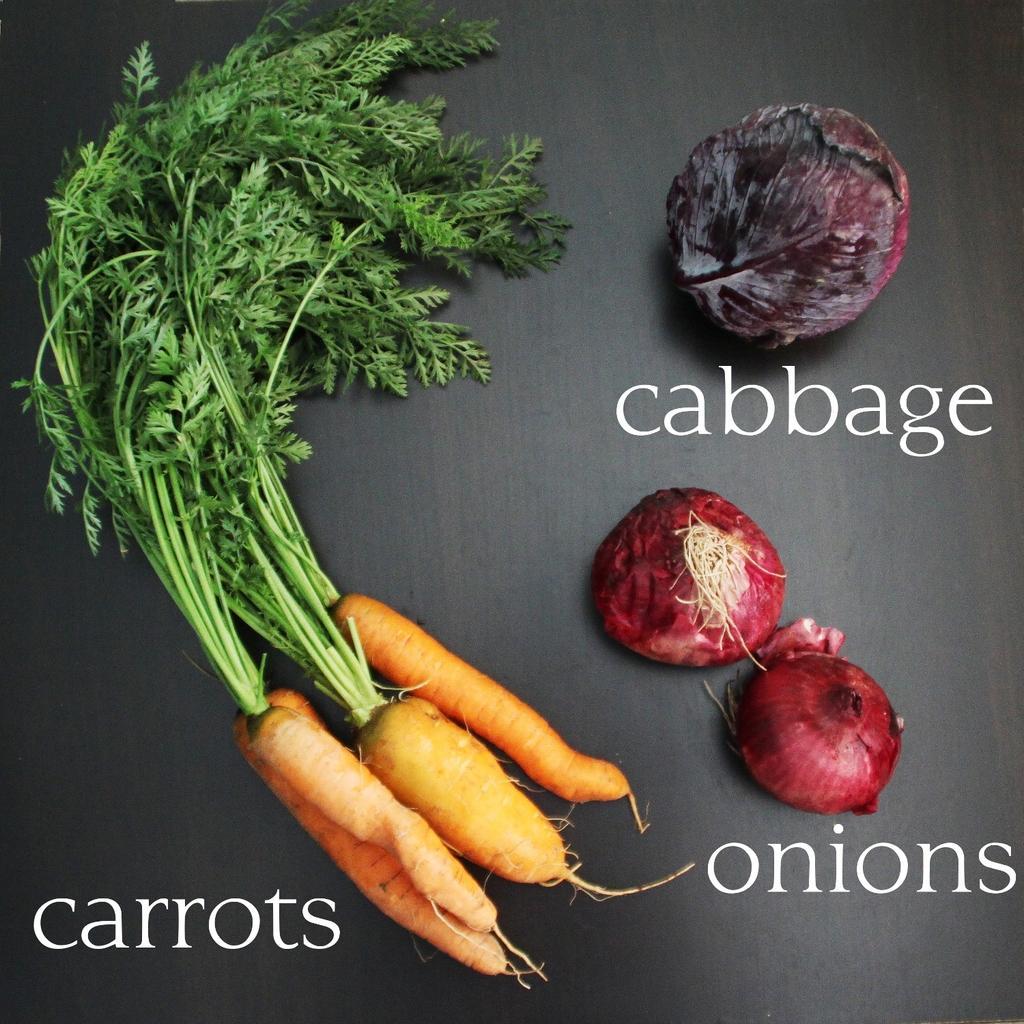Please provide a concise description of this image. As we can see in the image there are carrots, onions and a beetroot. 